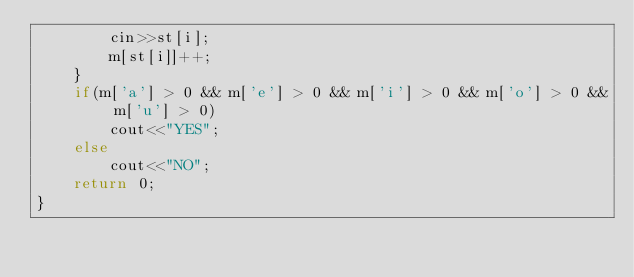<code> <loc_0><loc_0><loc_500><loc_500><_C++_>        cin>>st[i];
        m[st[i]]++;
    }
    if(m['a'] > 0 && m['e'] > 0 && m['i'] > 0 && m['o'] > 0 && m['u'] > 0)
        cout<<"YES";
    else
        cout<<"NO";
    return 0;
}
</code> 